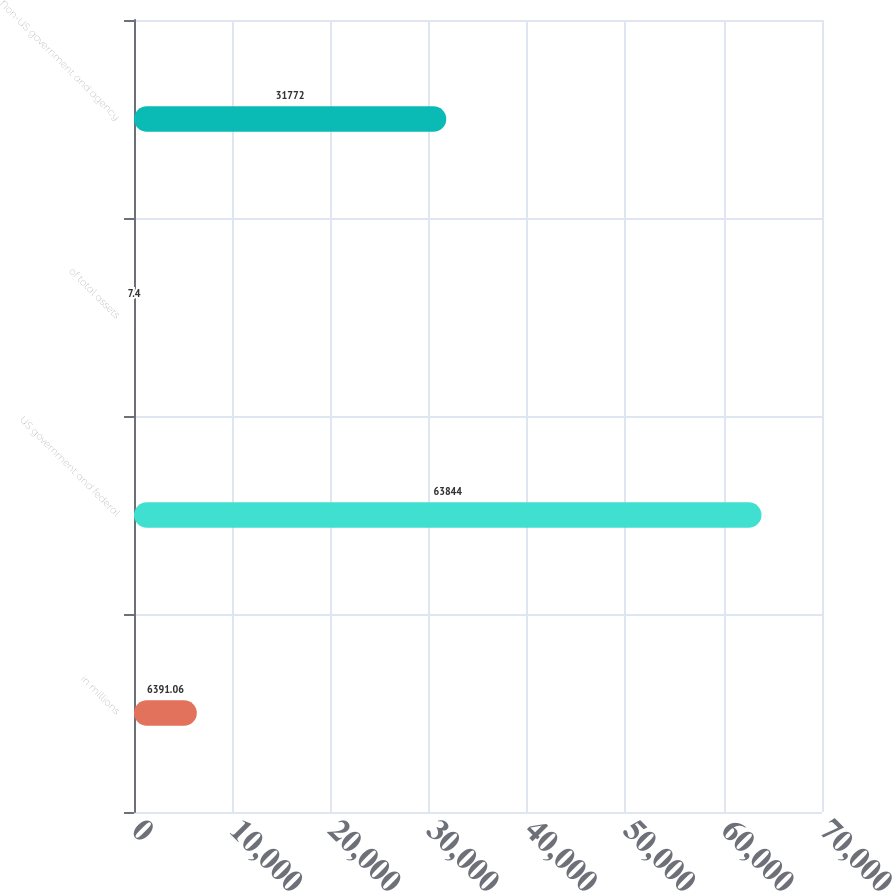Convert chart to OTSL. <chart><loc_0><loc_0><loc_500><loc_500><bar_chart><fcel>in millions<fcel>US government and federal<fcel>of total assets<fcel>Non-US government and agency<nl><fcel>6391.06<fcel>63844<fcel>7.4<fcel>31772<nl></chart> 